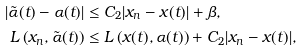Convert formula to latex. <formula><loc_0><loc_0><loc_500><loc_500>| \tilde { \alpha } ( t ) - \alpha ( t ) | & \leq C _ { 2 } | x _ { n } - x ( t ) | + \beta , \\ L \left ( x _ { n } , \tilde { \alpha } ( t ) \right ) & \leq L \left ( x ( t ) , \alpha ( t ) \right ) + C _ { 2 } | x _ { n } - x ( t ) | ,</formula> 